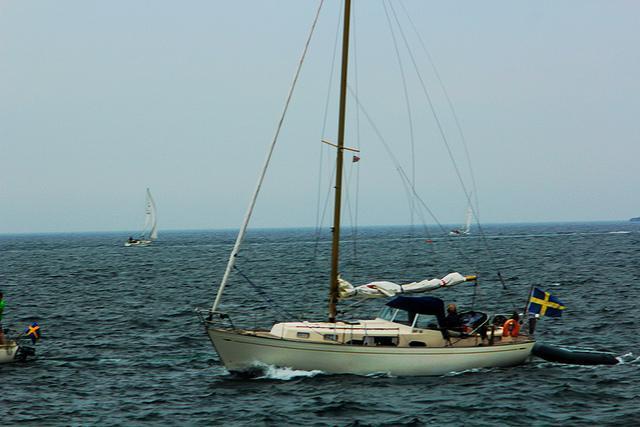How many dogs are running in the surf?
Give a very brief answer. 0. 